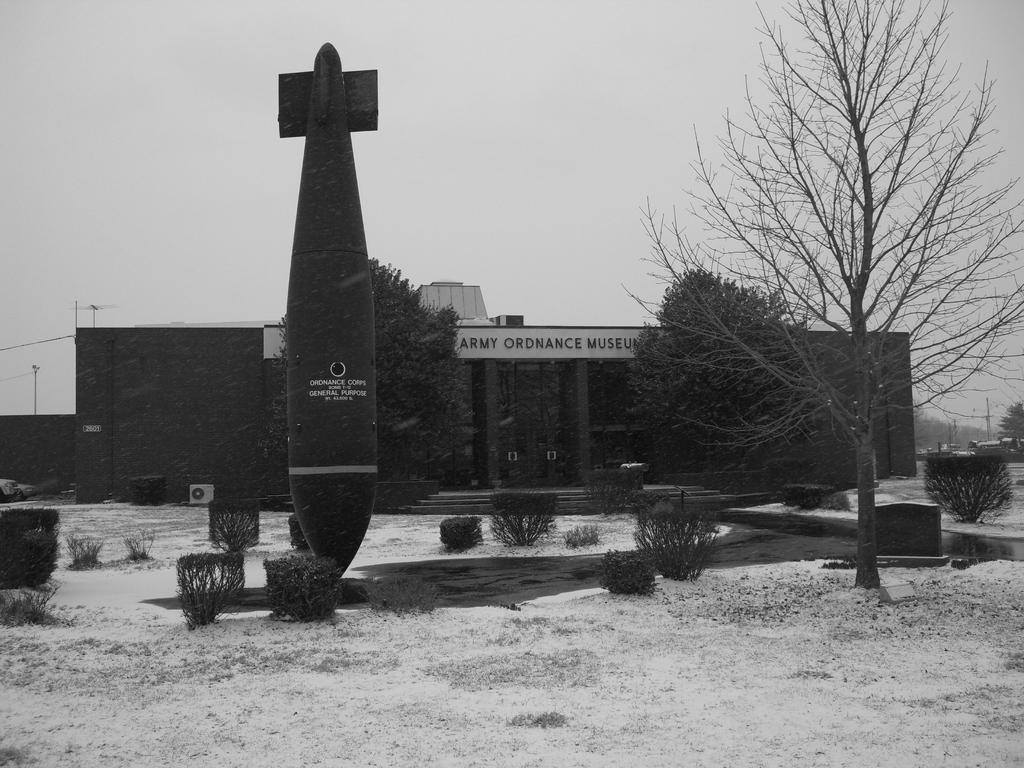Describe this image in one or two sentences. In the picture I can see an object and there are few plants beside it and there is a building which has something written on it and there are few trees in the right corner. 